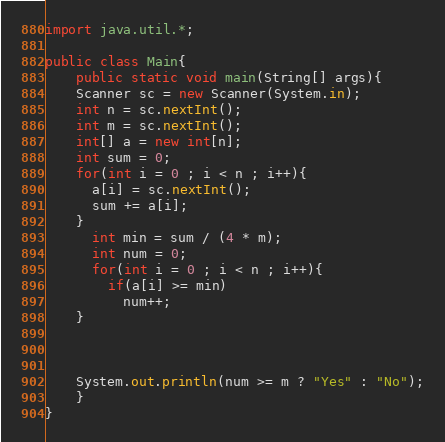Convert code to text. <code><loc_0><loc_0><loc_500><loc_500><_Java_>import java.util.*;

public class Main{
    public static void main(String[] args){
	Scanner sc = new Scanner(System.in);
	int n = sc.nextInt();
	int m = sc.nextInt();
    int[] a = new int[n];
    int sum = 0;
    for(int i = 0 ; i < n ; i++){
      a[i] = sc.nextInt();
      sum += a[i];
    }
      int min = sum / (4 * m);
      int num = 0;
      for(int i = 0 ; i < n ; i++){
        if(a[i] >= min)
          num++;
    }
    
      
	
	System.out.println(num >= m ? "Yes" : "No");
	}
}</code> 